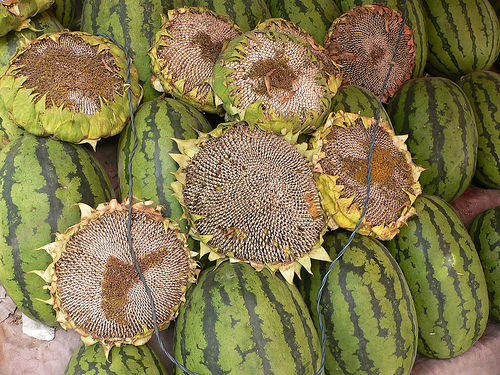<image>
Is there a sunflower in the watermelon? No. The sunflower is not contained within the watermelon. These objects have a different spatial relationship. 